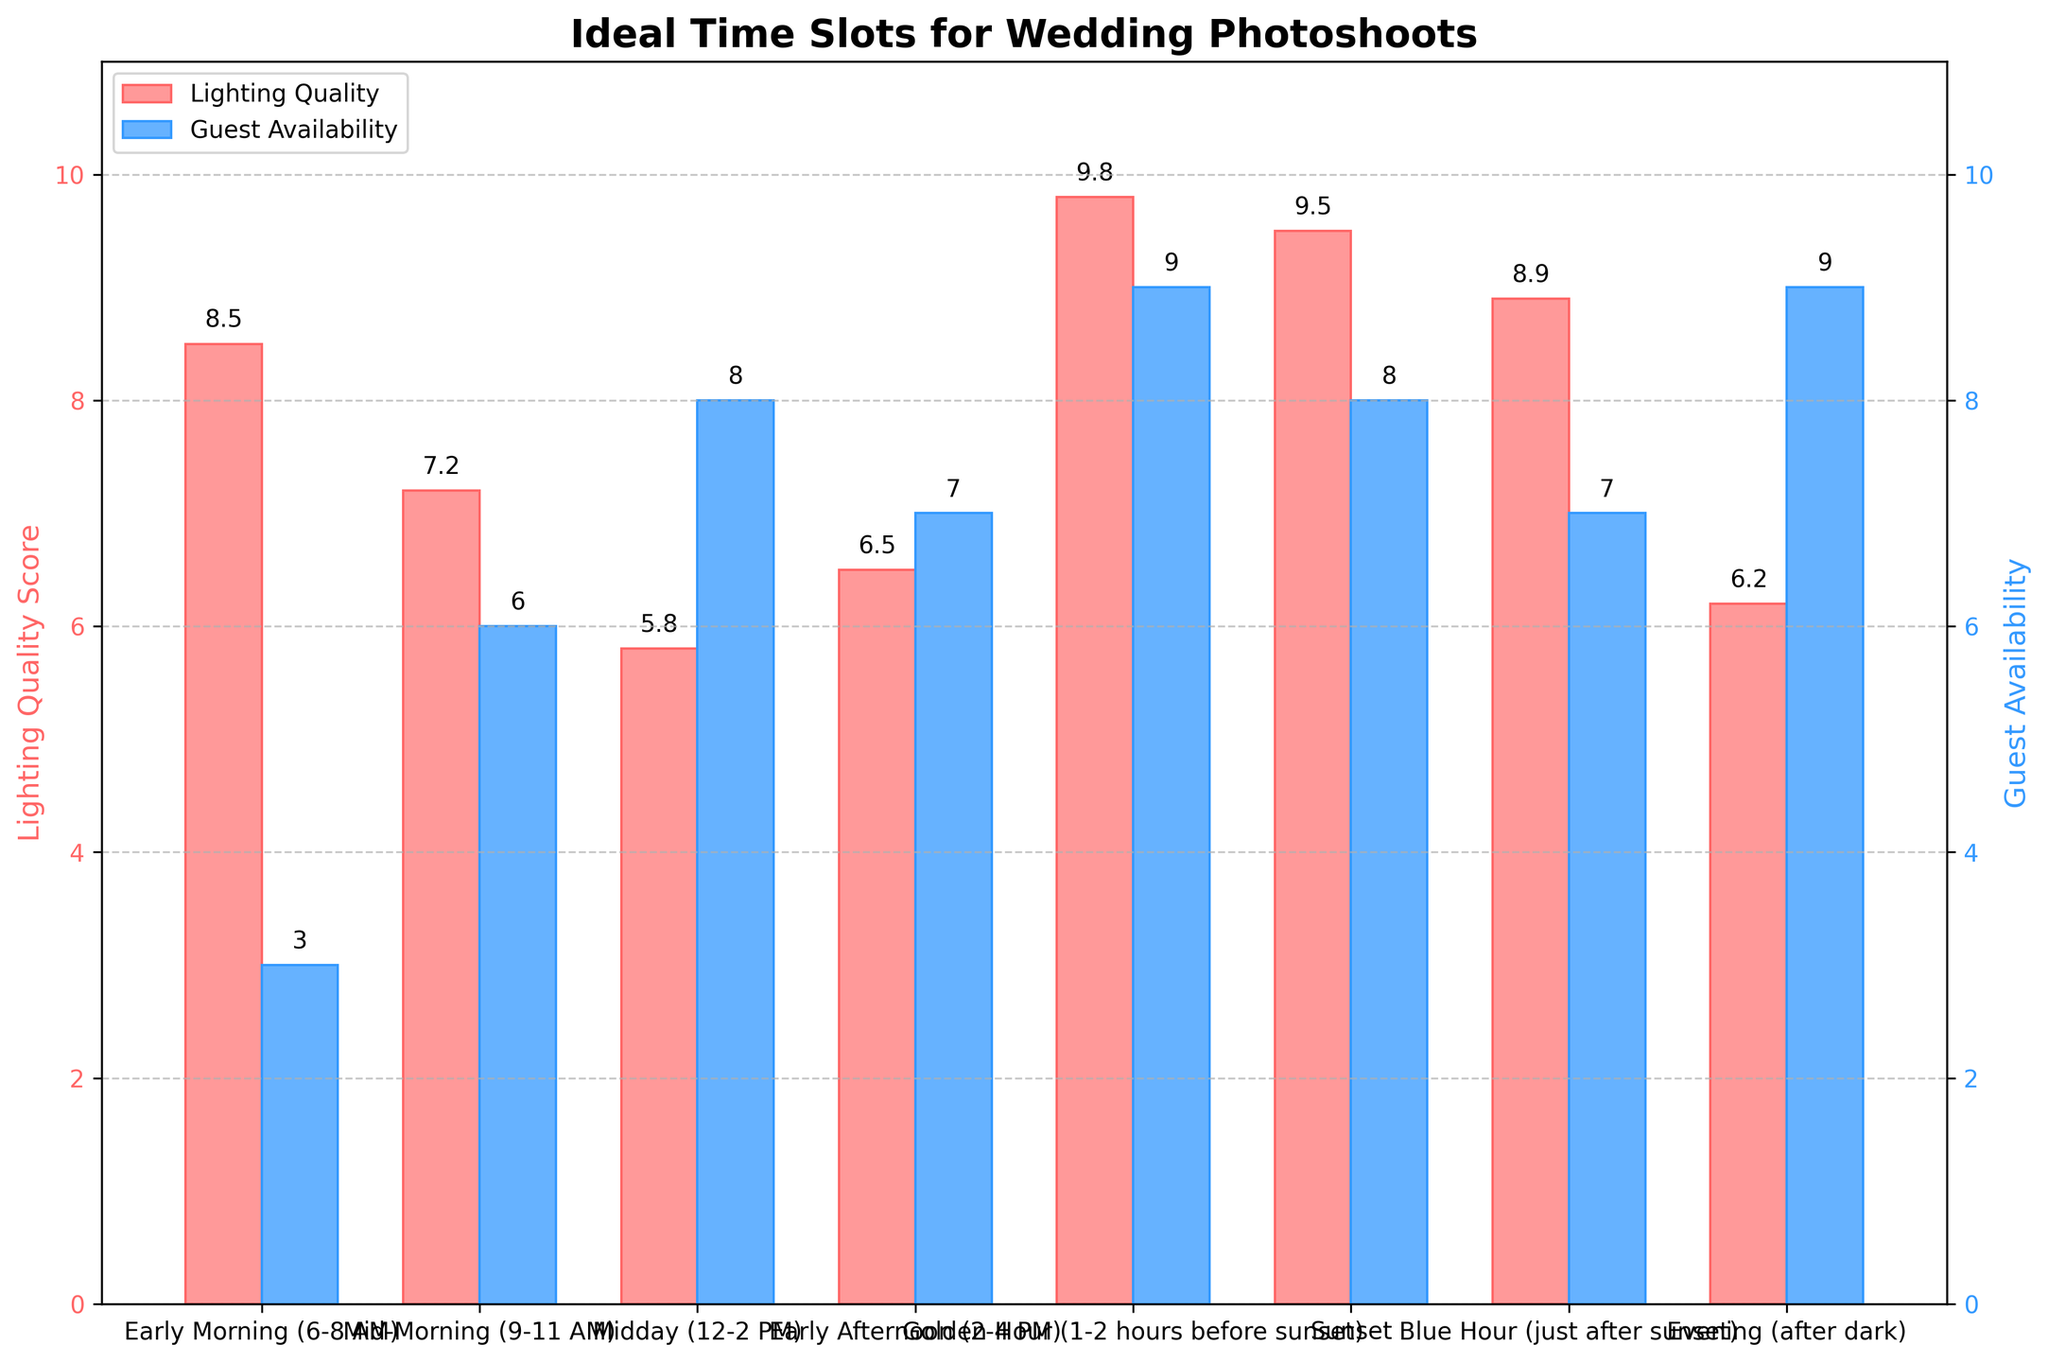Which time slot has the highest lighting quality score? Look at the height of the red bars representing the lighting quality score. The “Golden Hour” bar is the tallest.
Answer: Golden Hour Which time slot has the lowest guest availability? Compare the heights of the blue bars representing guest availability. The “Early Morning (6-8 AM)” bar is the shortest.
Answer: Early Morning (6-8 AM) What is the difference in lighting quality scores between Mid-Morning (9-11 AM) and Midday (12-2 PM)? Refer to the values above the red bars. Mid-Morning has a score of 7.2 and Midday has a score of 5.8. The difference is 7.2 - 5.8 = 1.4.
Answer: 1.4 Are there any time slots where lighting quality and guest availability both score 9 or higher? Check the red and blue bars for scores of 9 or higher. Only the “Golden Hour” fits this criterion.
Answer: Golden Hour Which time slot after dark has the highest guest availability? The time slot after dark mentioned is “Evening (after dark)”, and you need to look at the blue bar for this slot.
Answer: Evening (after dark) Which time slot has a higher lighting quality score: Early Afternoon (2-4 PM) or Evening (after dark)? Compare the heights of the red bars for these two time slots. Early Afternoon (2-4 PM) has a score of 6.5, which is higher than Evening (after dark) with a score of 6.2.
Answer: Early Afternoon (2-4 PM) How does the lighting quality score for Sunset compare to the Blue Hour? Look at the red bars for both “Sunset” and “Blue Hour”. Sunset has a score of 9.5 and Blue Hour has a score of 8.9.
Answer: Sunset is higher What is the total guest availability score if you combine Golden Hour and Evening (after dark)? Add the guest availability scores of these two time slots. Golden Hour has a score of 9 and Evening (after dark) has a score of 9. Hence, 9 + 9 = 18.
Answer: 18 What’s the average lighting quality score across all time slots? Sum all the lighting quality scores and divide by the number of time slots (8). (8.5 + 7.2 + 5.8 + 6.5 + 9.8 + 9.5 + 8.9 + 6.2) / 8 = 62.4 / 8 = 7.8
Answer: 7.8 Which time slot offers the best balance between lighting quality and guest availability? Look for the slot where both the red and blue bars are relatively high. “Golden Hour” has the highest lighting quality score and high guest availability.
Answer: Golden Hour 